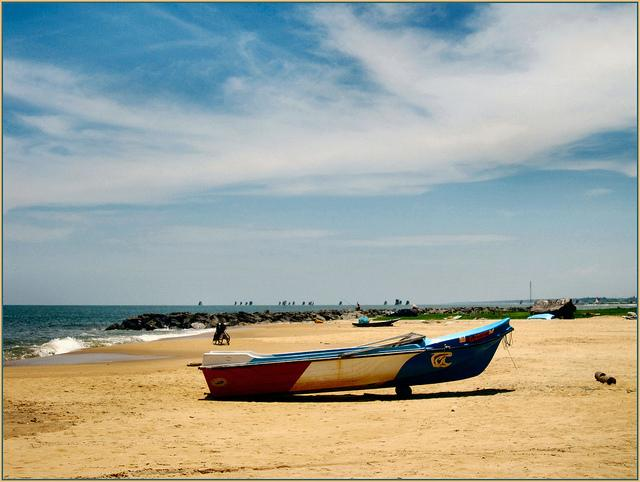Who might use the boat on the beach? fisherman 